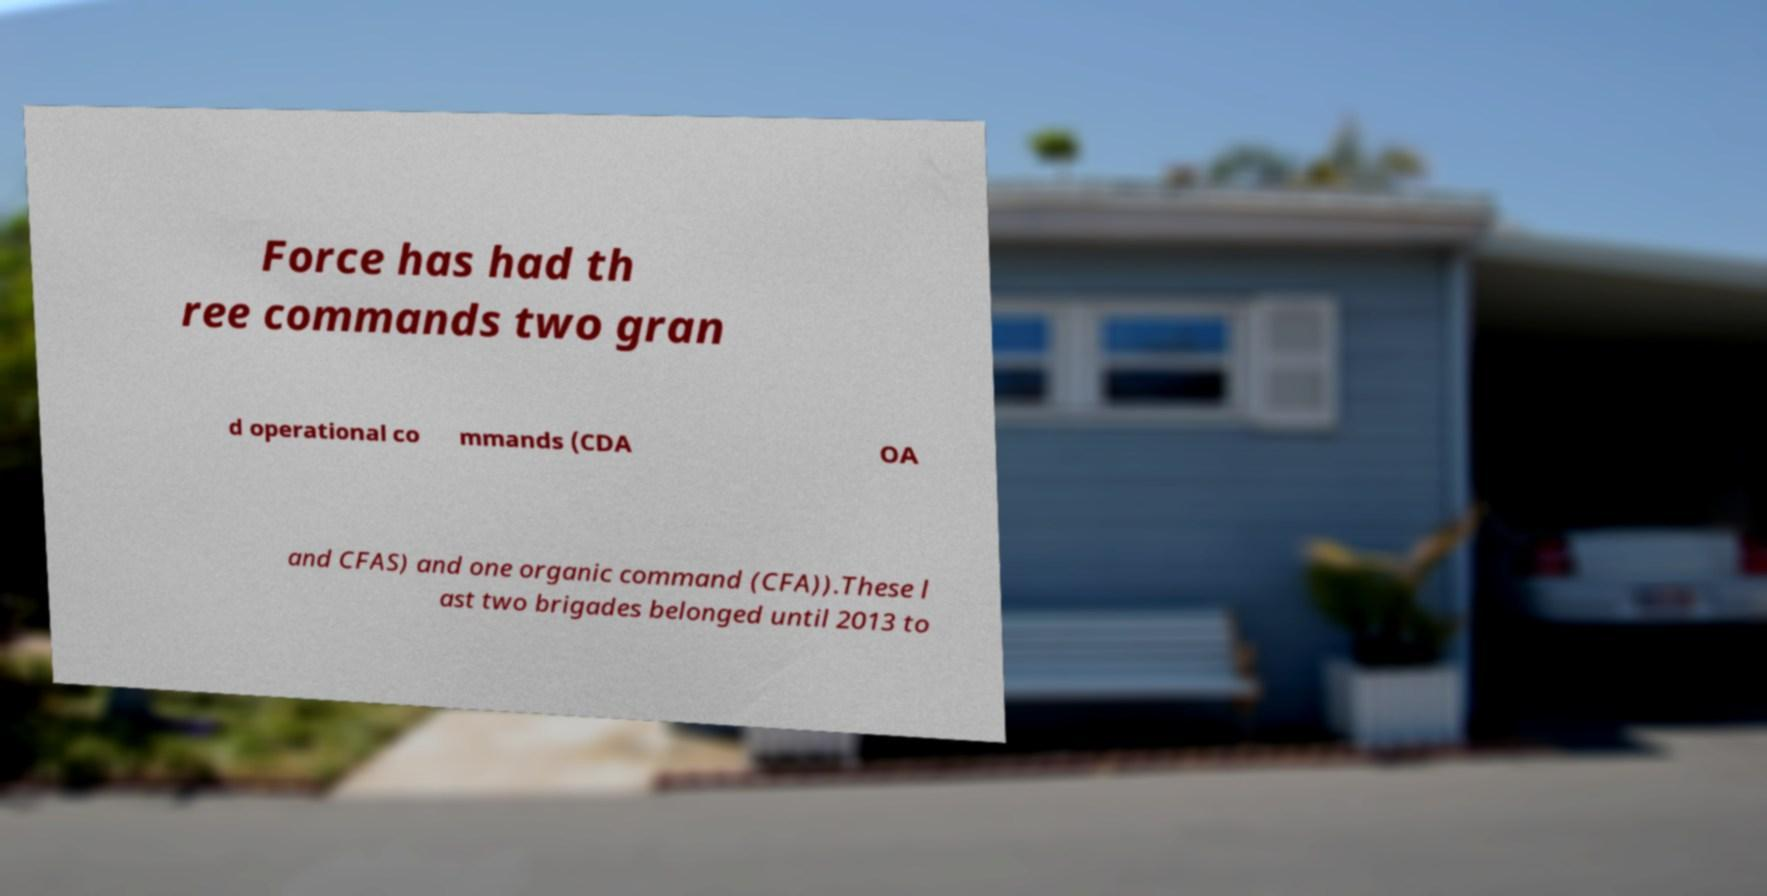For documentation purposes, I need the text within this image transcribed. Could you provide that? Force has had th ree commands two gran d operational co mmands (CDA OA and CFAS) and one organic command (CFA)).These l ast two brigades belonged until 2013 to 